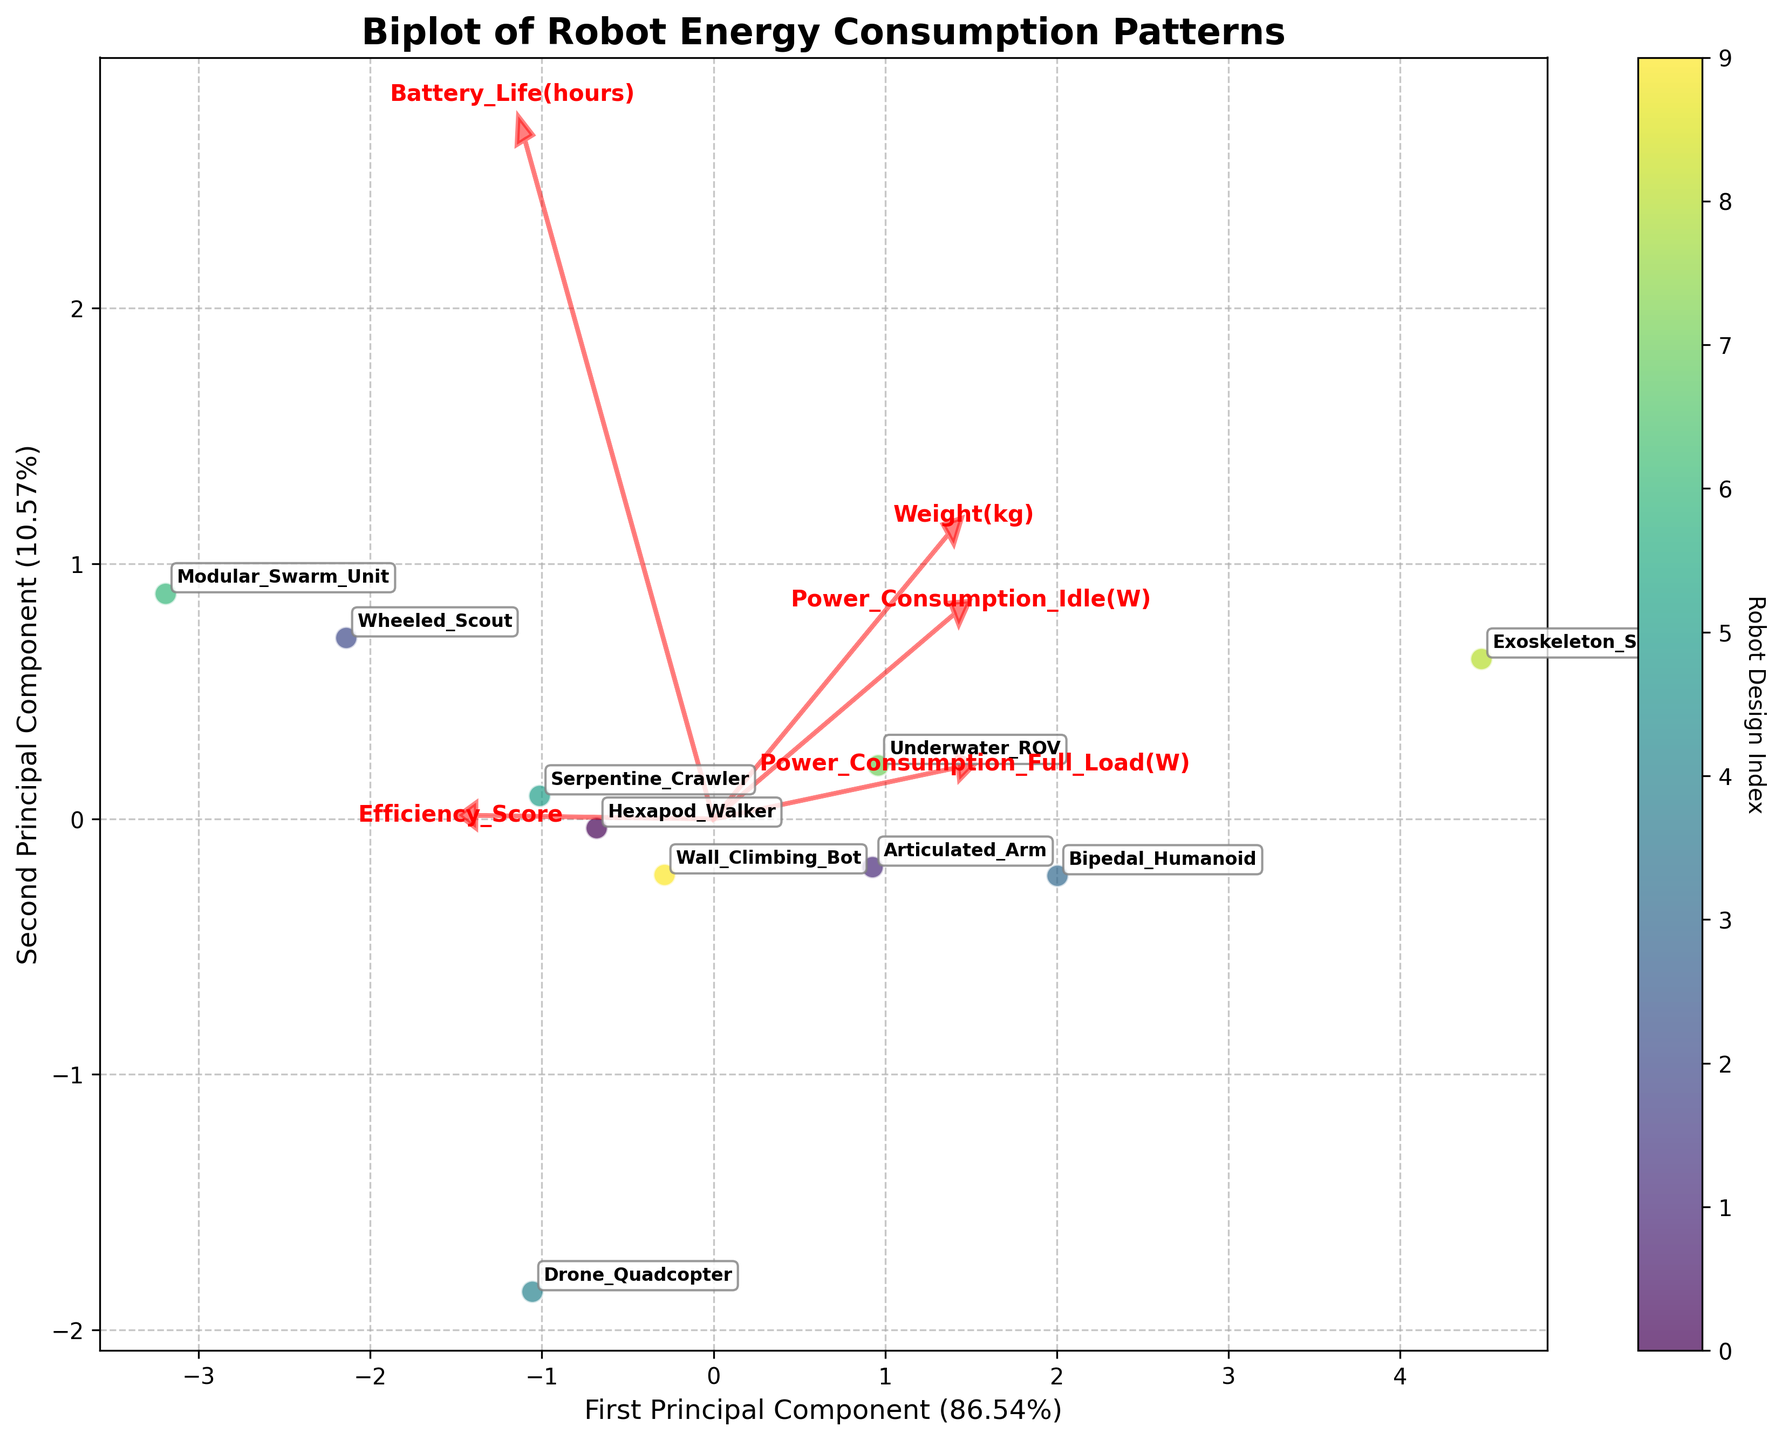What is the title of the plot? The title of the plot is typically displayed prominently at the top of the figure. In this case, the title "Biplot of Robot Energy Consumption Patterns" is clearly stated.
Answer: Biplot of Robot Energy Consumption Patterns What are the labels of the X and Y axes? The X and Y axis labels are usually found next to the respective axes. Here, the X-axis is labeled "First Principal Component" and the Y-axis is labeled "Second Principal Component".
Answer: First Principal Component and Second Principal Component Which robot design has the highest first principal component value? To determine this, we look for the data point located furthest to the right on the X-axis of the plot. According to the figure, the "Modular_Swarm_Unit" appears to have the highest first principal component value.
Answer: Modular_Swarm_Unit Which variable is represented by the red arrow that points maximally towards the right? Each red arrow represents a variable, and the direction of the arrow indicates the orientation in relation to the principal components. The red arrow pointing maximally towards the right represents the variable that has the highest positive loading on the first principal component. This is "Power_Consumption_Full_Load(W)".
Answer: Power_Consumption_Full_Load(W) Which robot design has the smallest second principal component value? To answer this, find the data point located closest to the bottom of the Y-axis. The "Exoskeleton_Suit" is positioned lowest on the Y-axis, indicating it has the smallest second principal component value.
Answer: Exoskeleton_Suit How does the weight of the "Drone_Quadcopter" compare with the weight of the "Hexapod_Walker"? We must look at the directions of their respective PCA scores in relation to the red arrow labeled "Weight(kg)". The "Hexapod_Walker" is positioned slightly towards the arrow for "Weight(kg)" compared to the "Drone_Quadcopter," indicating the "Hexapod_Walker" is heavier.
Answer: Hexapod_Walker is heavier Which robot designs are closest in their energy consumption patterns? Examining the data points located nearest to each other on the biplot will give us an idea of the robots with similar energy consumption patterns. The "Wheeled_Scout" and "Serpentine_Crawler" are close to each other, indicating similar patterns.
Answer: Wheeled_Scout and Serpentine_Crawler What percentage of the variance is explained by the first principal component? This information is usually indicated by the axis label. In the figure, the label of the X-axis (First Principal Component) shows it explains approximately 47.86% of the variance.
Answer: 47.86% Which robot design has a high battery life as indicated on the biplot? The arrow pointing towards higher values of "Battery_Life(hours)" allows us to determine which data point is in that direction. The "Modular_Swarm_Unit" is in the direction of the arrow, suggesting it has a high battery life.
Answer: Modular_Swarm_Unit 